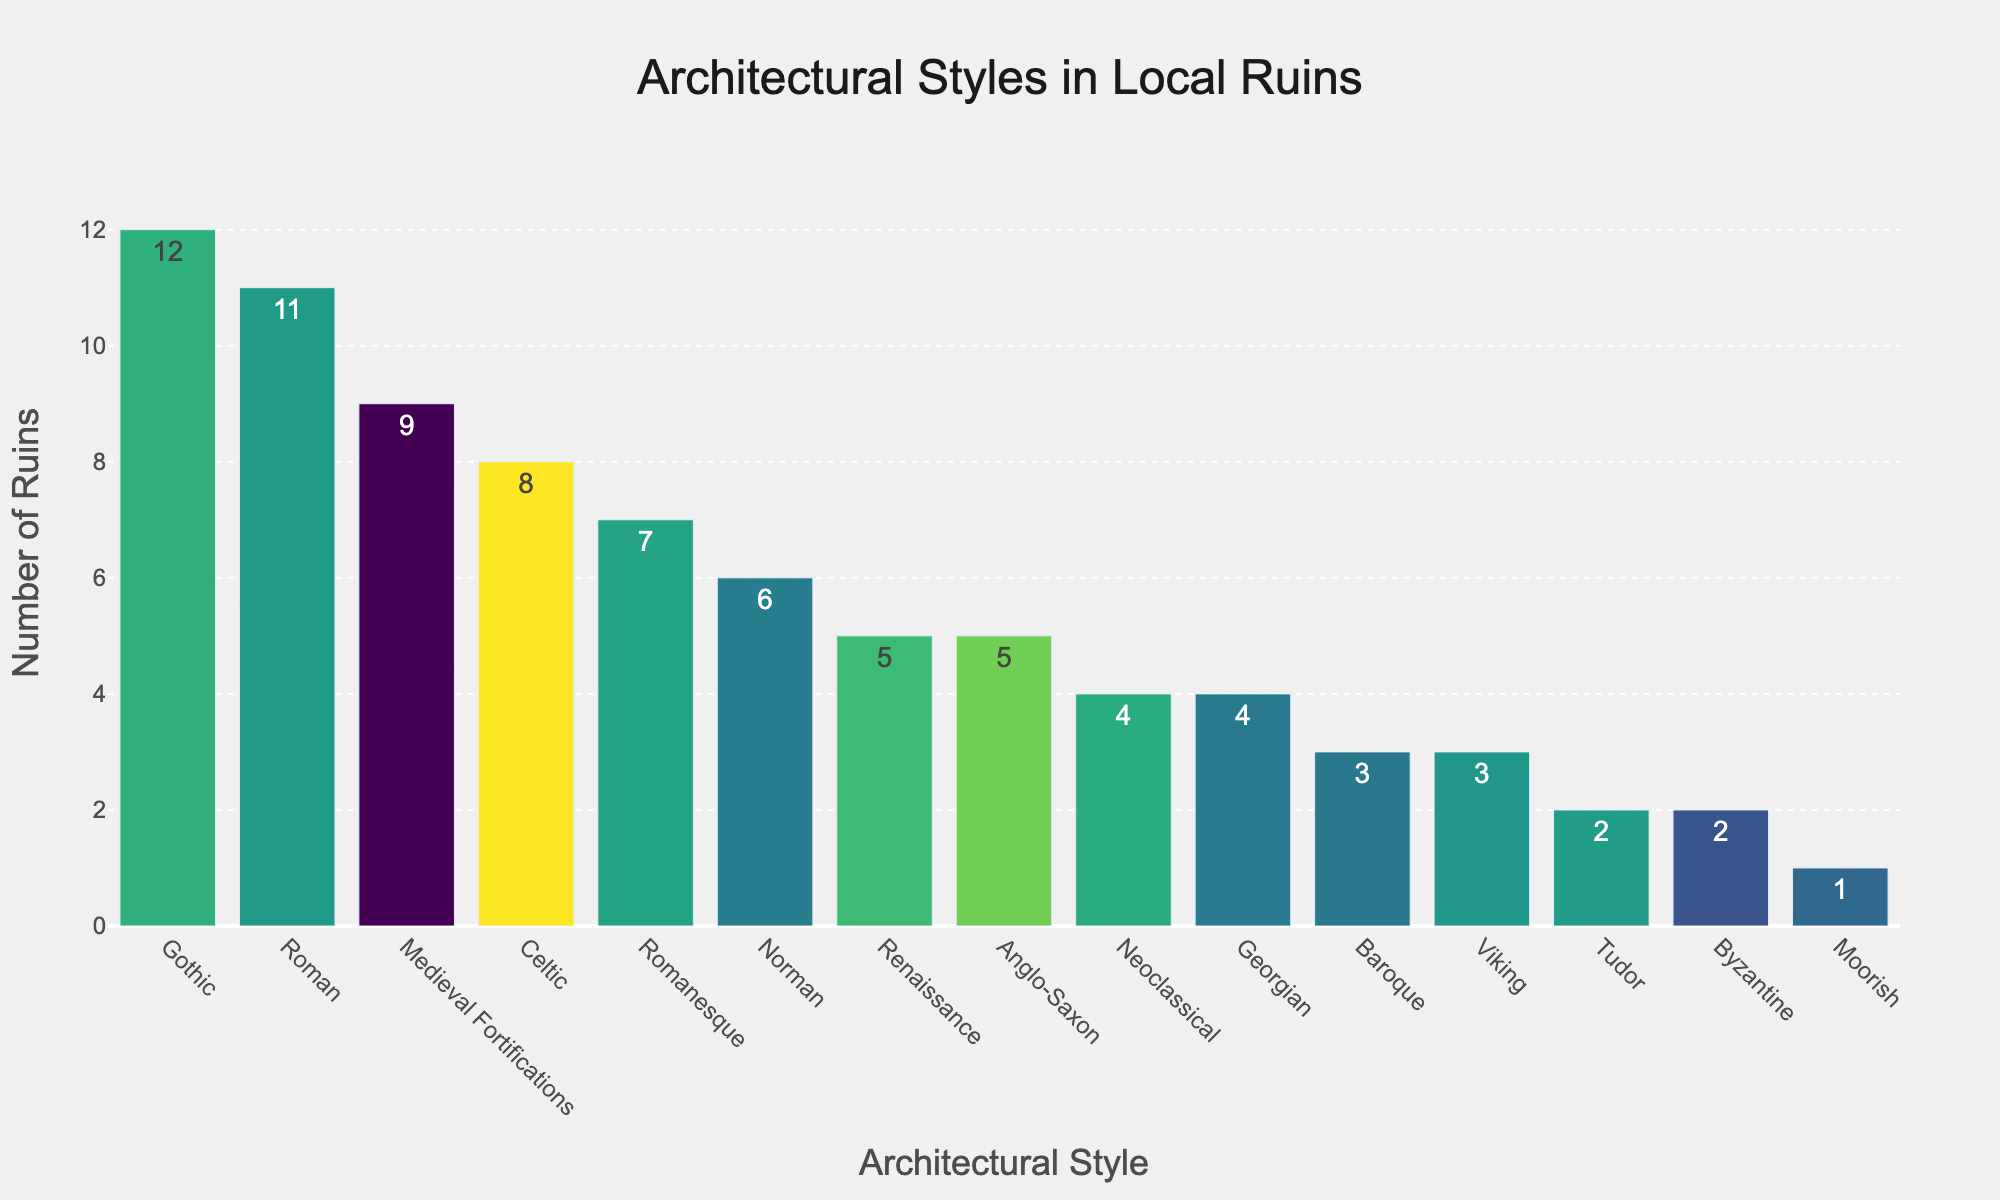Which architectural style has the highest number of ruins? The bar representing Gothic architectural style is the tallest, indicating it has the highest number of ruins.
Answer: Gothic Which styles have exactly five ruins? By locating the bars with a height corresponding to five ruins, we identify Renaissance and Anglo-Saxon styles.
Answer: Renaissance and Anglo-Saxon How many more ruins does the Gothic style have compared to the Roman style? Gothic has 12 ruins and Roman has 11. Subtracting the two gives: 12 - 11 = 1.
Answer: 1 Which style has the least number of ruins, and how many does it have? The shortest bar corresponds to the Moorish style, which has just 1 ruin.
Answer: Moorish, 1 Compare the number of ruins in the Romanesque and Norman styles. Which one has more, and by how many? Romanesque has 7 ruins and Norman has 6. Subtract to find the difference: 7 - 6 = 1. Romanesque has one more ruin.
Answer: Romanesque, 1 What is the total number of ruins for all architectural styles listed? Add all the values: 7 + 12 + 5 + 3 + 4 + 9 + 6 + 2 + 8 + 5 + 3 + 11 + 2 + 1 + 4 = 82.
Answer: 82 Is the average number of ruins across all architectural styles greater than 5? Calculate the average by dividing the total number of ruins (82) by the number of styles (15). The average is 82 / 15 ≈ 5.47, which is greater than 5.
Answer: Yes Which styles have more ruins than the average number of ruins? The average number of ruins is 5.47. The styles with more than 5.47 ruins are Gothic (12), Medieval Fortifications (9), Roman (11), and Celtic (8).
Answer: Gothic, Medieval Fortifications, Roman, Celtic What are the cumulative number of ruins for Romanesque and Gothic styles combined? Add the number of ruins for Romanesque (7) and Gothic (12): 7 + 12 = 19.
Answer: 19 